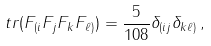Convert formula to latex. <formula><loc_0><loc_0><loc_500><loc_500>\ t r ( F _ { ( i } F _ { j } F _ { k } F _ { \ell ) } ) = \frac { 5 } { 1 0 8 } \delta _ { ( i j } \delta _ { k \ell ) } \, ,</formula> 